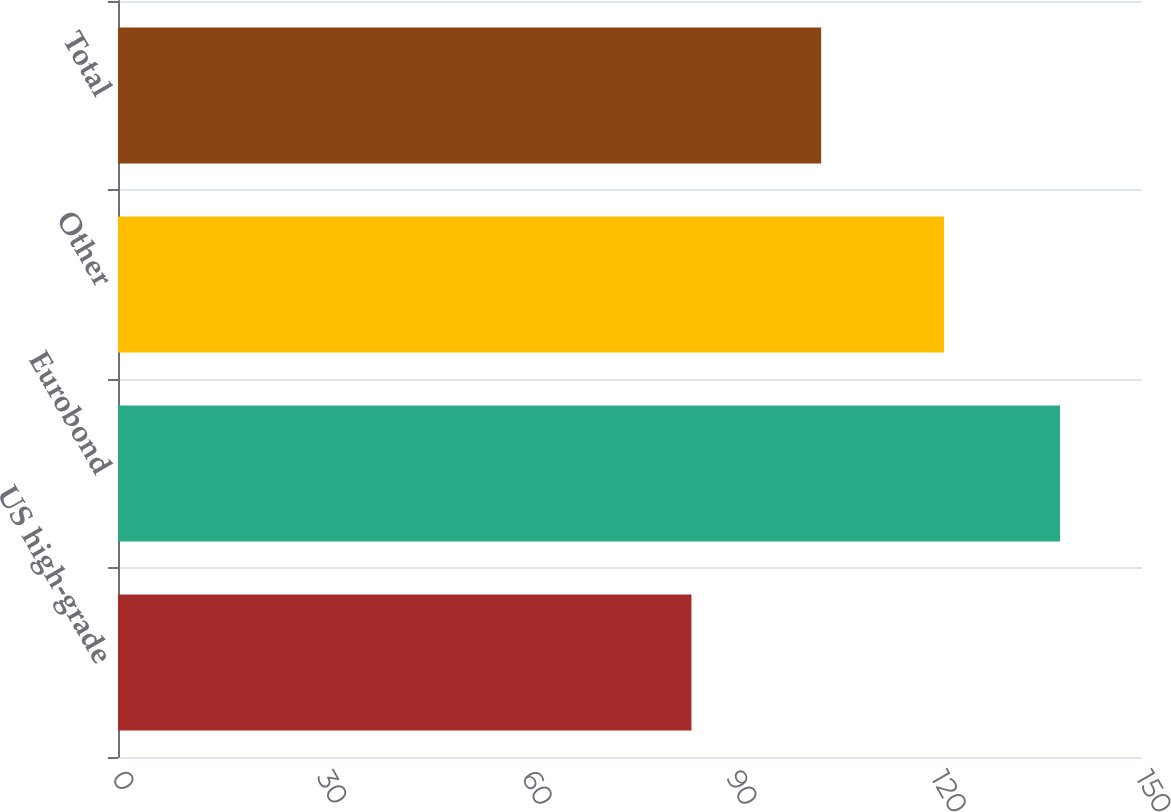<chart> <loc_0><loc_0><loc_500><loc_500><bar_chart><fcel>US high-grade<fcel>Eurobond<fcel>Other<fcel>Total<nl><fcel>84<fcel>138<fcel>121<fcel>103<nl></chart> 